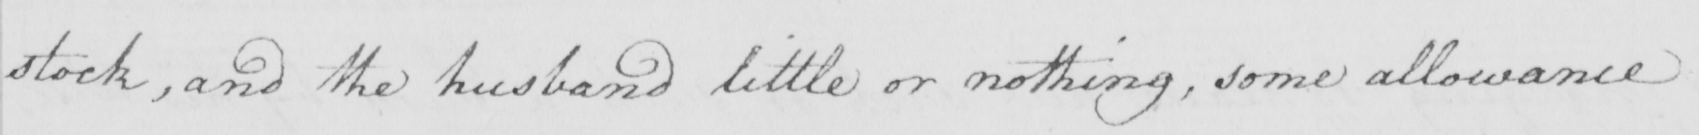What text is written in this handwritten line? stock , and the husband little or nothing , some allowance 